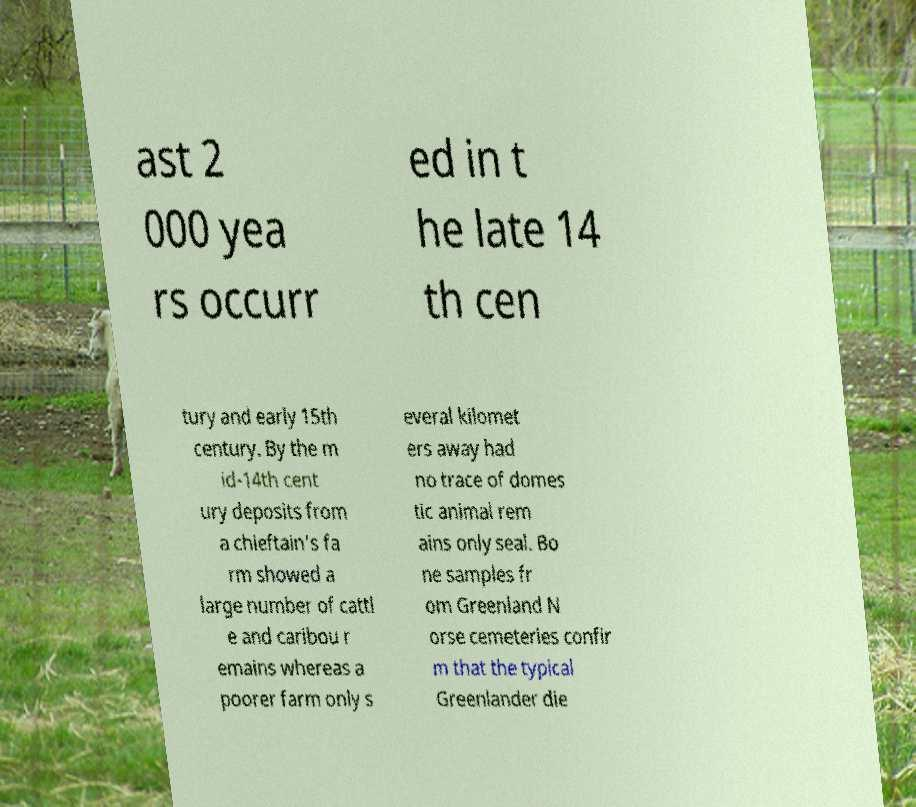Could you extract and type out the text from this image? ast 2 000 yea rs occurr ed in t he late 14 th cen tury and early 15th century. By the m id-14th cent ury deposits from a chieftain's fa rm showed a large number of cattl e and caribou r emains whereas a poorer farm only s everal kilomet ers away had no trace of domes tic animal rem ains only seal. Bo ne samples fr om Greenland N orse cemeteries confir m that the typical Greenlander die 